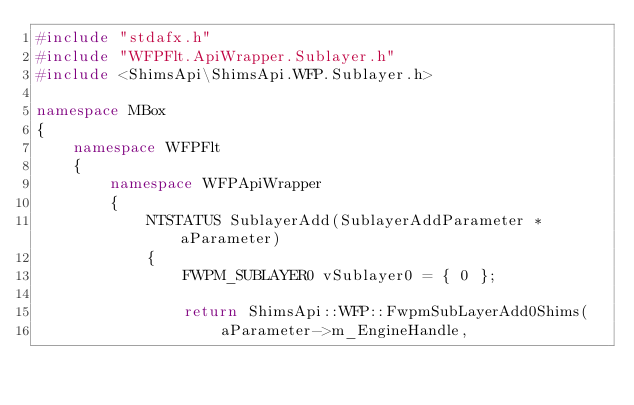<code> <loc_0><loc_0><loc_500><loc_500><_C++_>#include "stdafx.h"
#include "WFPFlt.ApiWrapper.Sublayer.h"
#include <ShimsApi\ShimsApi.WFP.Sublayer.h>

namespace MBox
{
    namespace WFPFlt
    {
        namespace WFPApiWrapper
        {
            NTSTATUS SublayerAdd(SublayerAddParameter * aParameter)
            {
                FWPM_SUBLAYER0 vSublayer0 = { 0 };

                return ShimsApi::WFP::FwpmSubLayerAdd0Shims(
                    aParameter->m_EngineHandle,</code> 